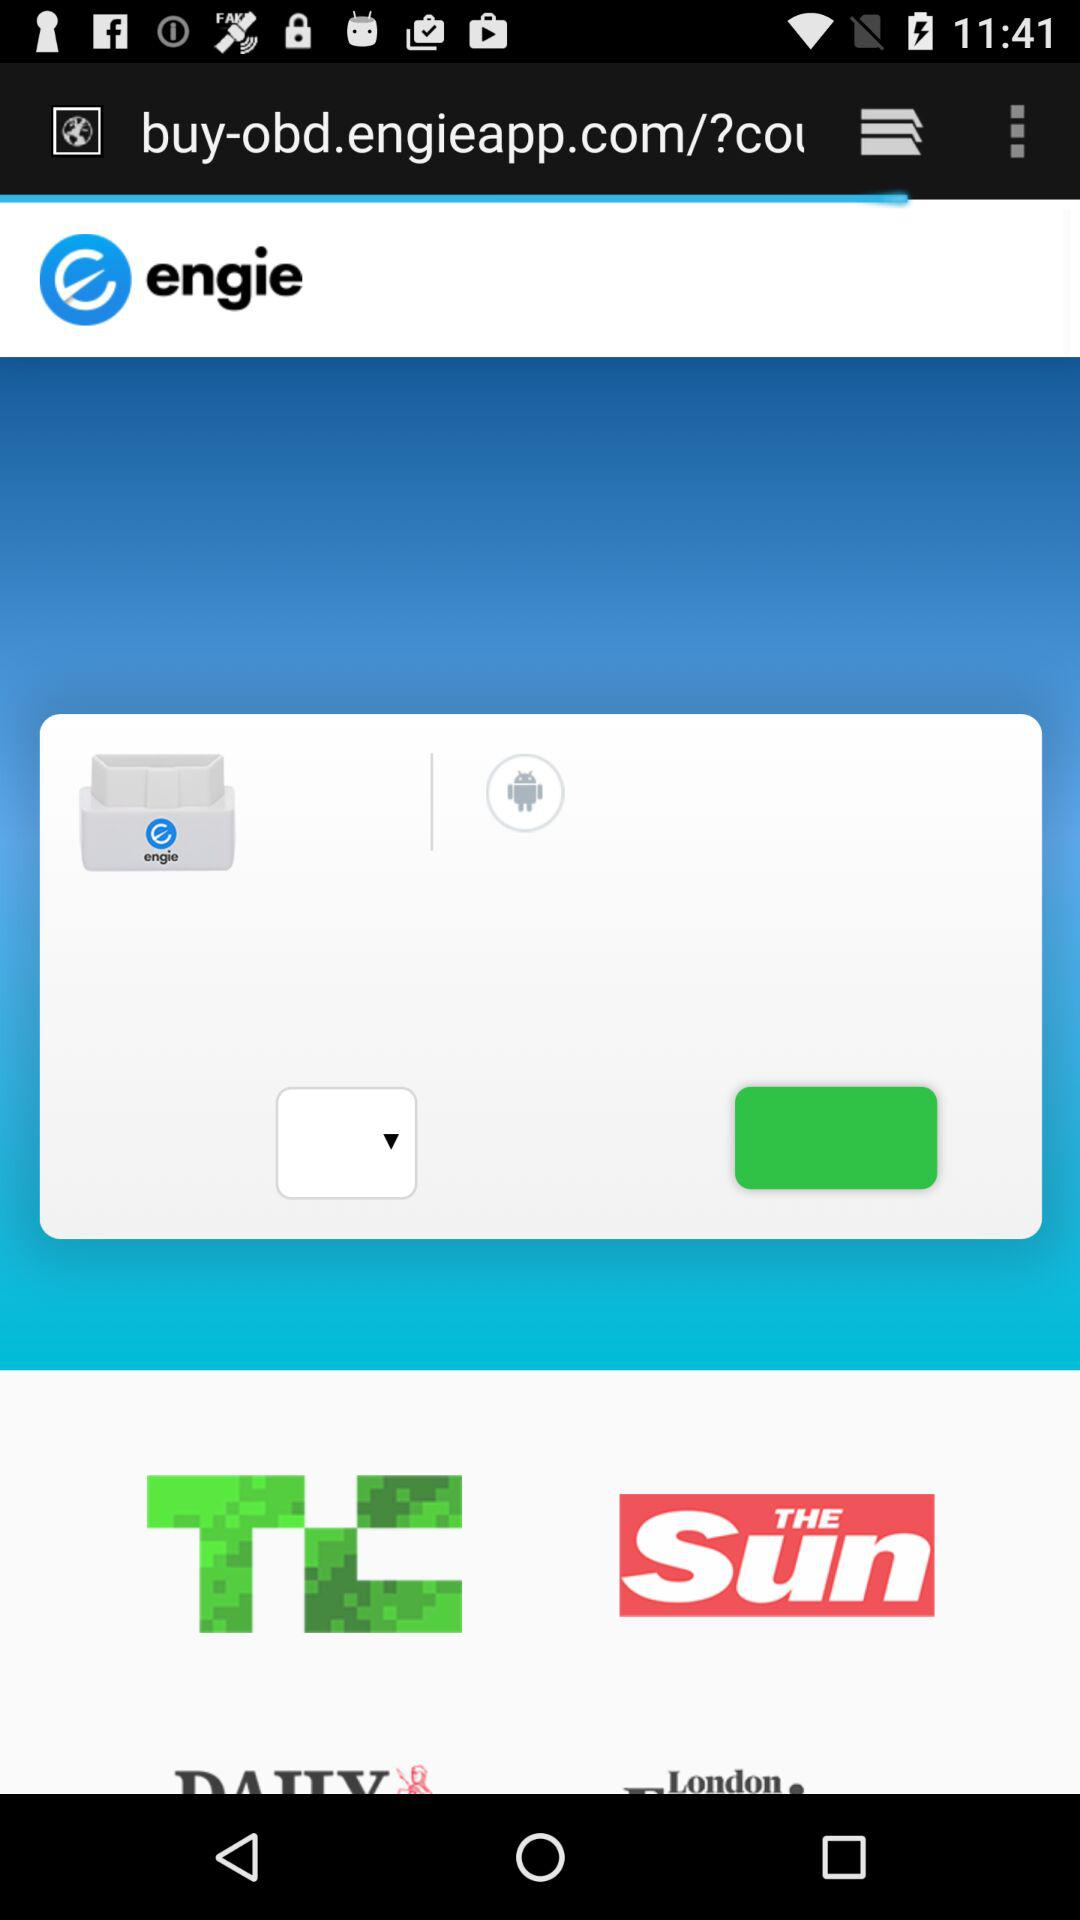What is the name of the application? The name of the application is "engie". 